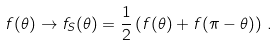Convert formula to latex. <formula><loc_0><loc_0><loc_500><loc_500>f ( \theta ) \to f _ { S } ( \theta ) = \frac { 1 } { 2 } \left ( f ( \theta ) + f ( \pi - \theta ) \right ) \, .</formula> 